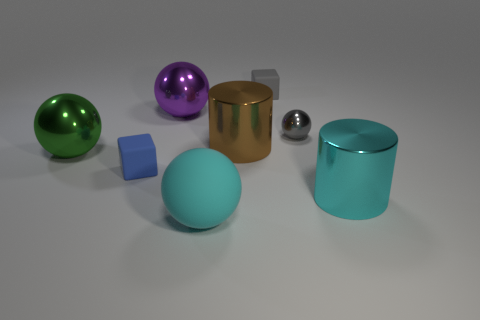Add 1 cyan cylinders. How many objects exist? 9 Subtract all cylinders. How many objects are left? 6 Add 7 tiny objects. How many tiny objects exist? 10 Subtract 1 purple spheres. How many objects are left? 7 Subtract all big brown metal cylinders. Subtract all tiny blocks. How many objects are left? 5 Add 7 gray blocks. How many gray blocks are left? 8 